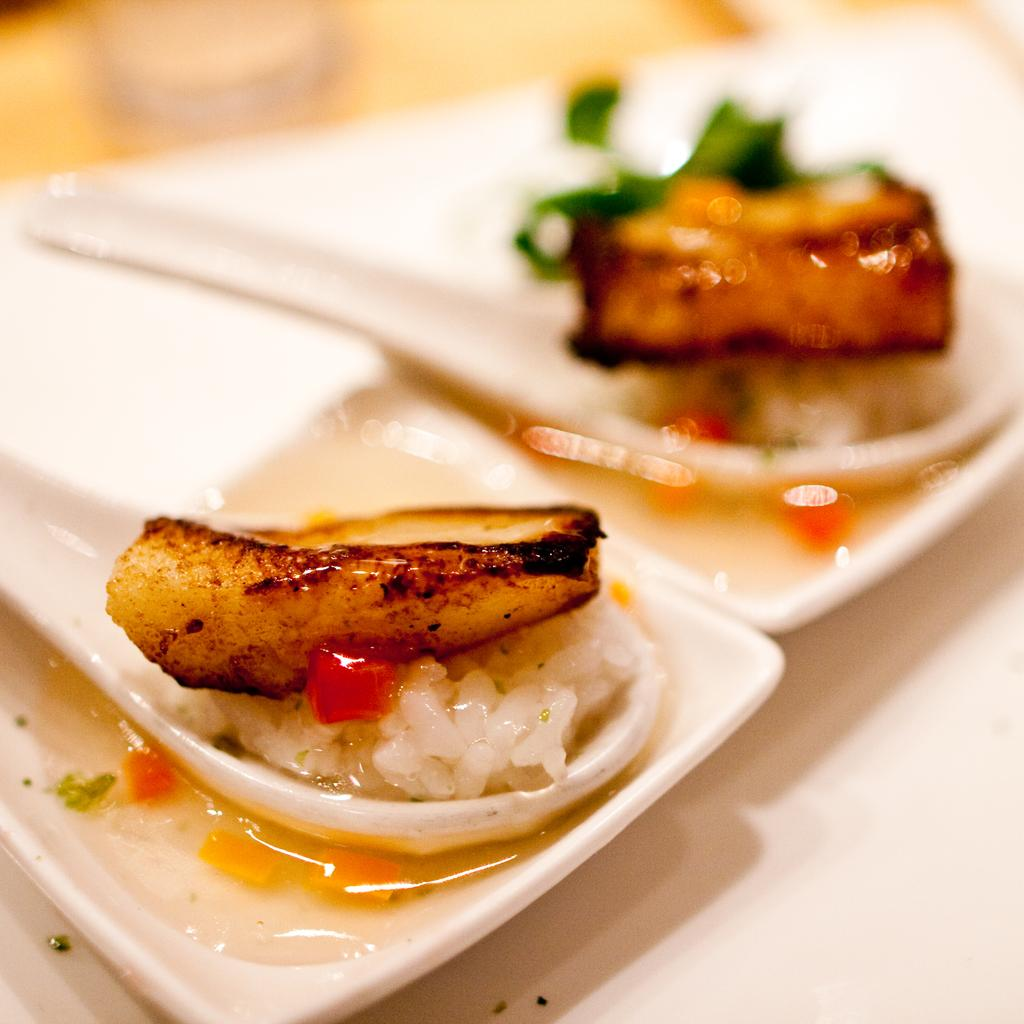What is the main object in the image? There is a table in the image. What is on the table? Food items are placed on the table. How are the food items arranged on the table? The food items are on plates. What part of the image is in focus? The bottom of the image consists of the table. What is the condition of the top part of the image? The top of the image is blurred. What type of operation is being performed on the dolls in the image? There are no dolls present in the image, and therefore no operation is being performed. What type of legal advice is the lawyer providing in the image? There is no lawyer present in the image, and therefore no legal advice is being provided. 